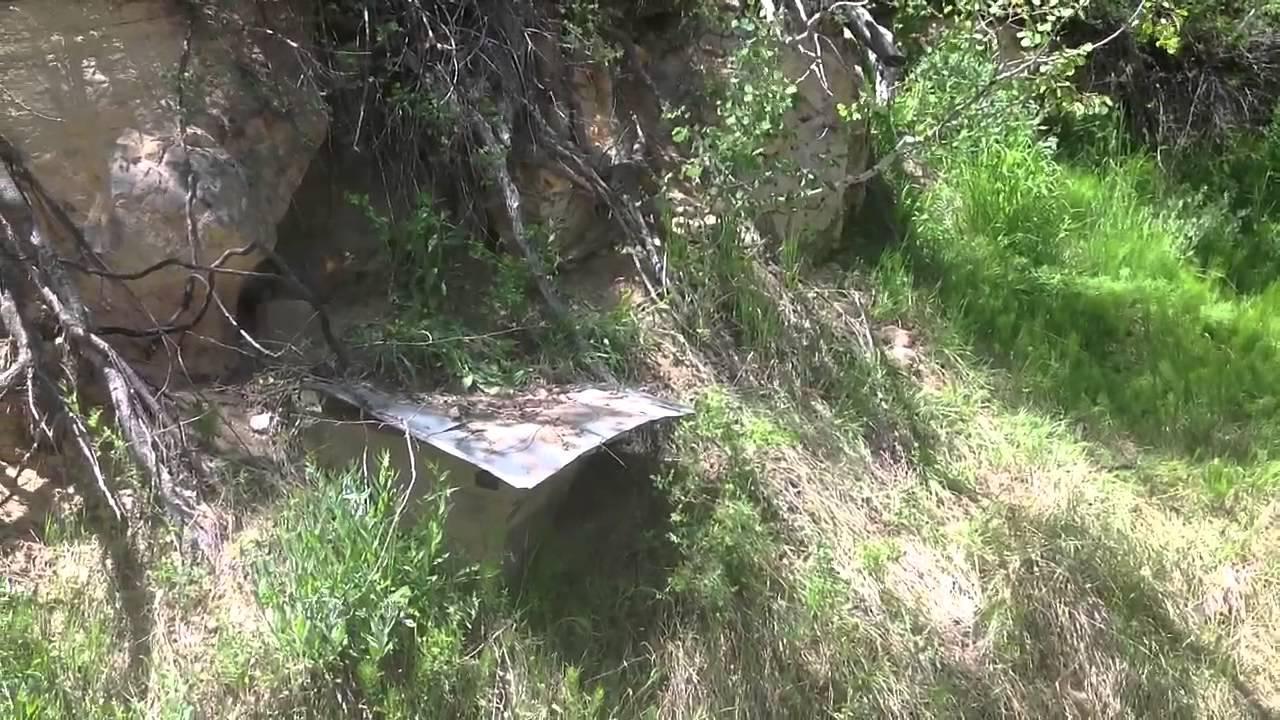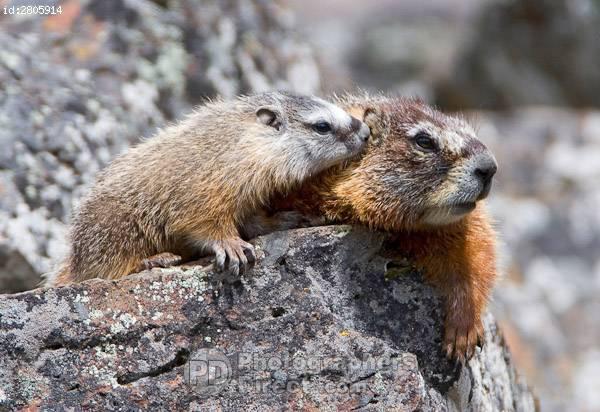The first image is the image on the left, the second image is the image on the right. Examine the images to the left and right. Is the description "The left and right image contains the same number of prairie dogs." accurate? Answer yes or no. No. The first image is the image on the left, the second image is the image on the right. Considering the images on both sides, is "There is at least two rodents in the right image." valid? Answer yes or no. Yes. 